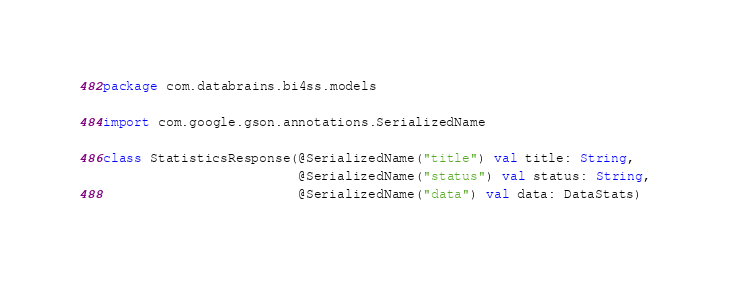<code> <loc_0><loc_0><loc_500><loc_500><_Kotlin_>package com.databrains.bi4ss.models

import com.google.gson.annotations.SerializedName

class StatisticsResponse(@SerializedName("title") val title: String,
                         @SerializedName("status") val status: String,
                         @SerializedName("data") val data: DataStats)</code> 